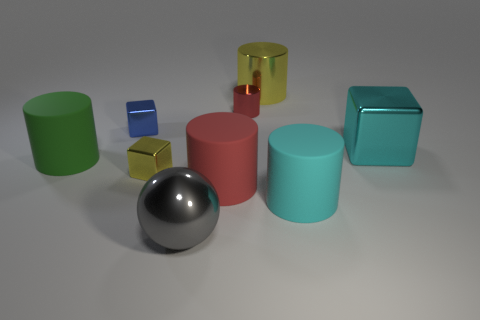Subtract 1 cylinders. How many cylinders are left? 4 Subtract all cyan cylinders. How many cylinders are left? 4 Subtract all cyan cylinders. How many cylinders are left? 4 Subtract all purple cylinders. Subtract all gray balls. How many cylinders are left? 5 Subtract all balls. How many objects are left? 8 Add 6 large green matte objects. How many large green matte objects exist? 7 Subtract 0 yellow spheres. How many objects are left? 9 Subtract all big purple metallic spheres. Subtract all big cyan shiny cubes. How many objects are left? 8 Add 1 green rubber things. How many green rubber things are left? 2 